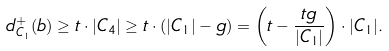<formula> <loc_0><loc_0><loc_500><loc_500>d ^ { + } _ { C _ { 1 } } ( b ) \geq t \cdot | C _ { 4 } | \geq t \cdot ( | C _ { 1 } | - g ) = \left ( t - \frac { t g } { | C _ { 1 } | } \right ) \cdot | C _ { 1 } | .</formula> 